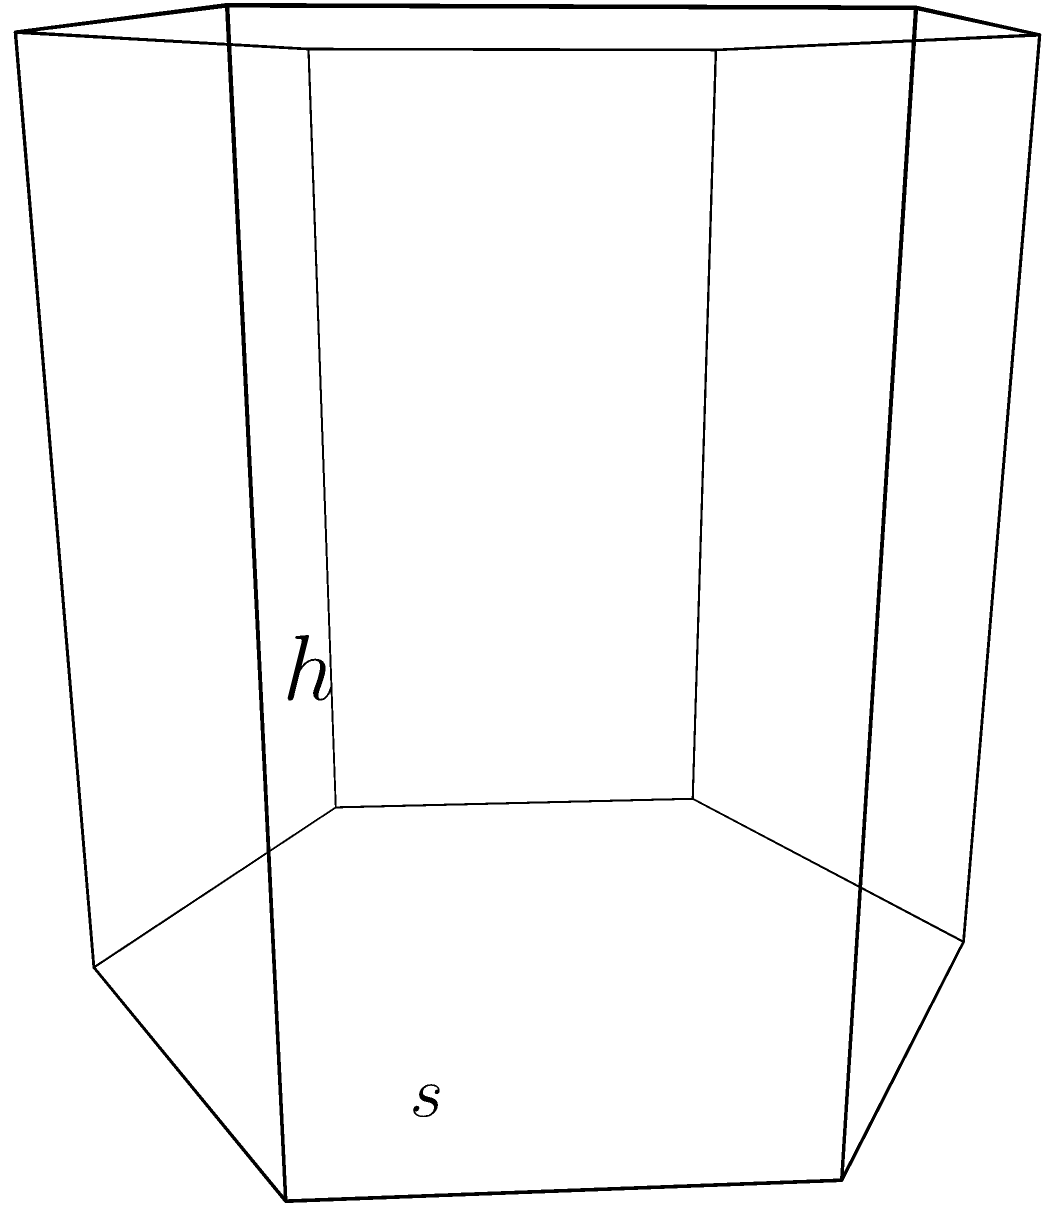As a professional bookmaker, you're designing a question about solid geometry. Consider a regular hexagonal prism with side length $s$ and height $h$. How would you express the lateral surface area of this prism in terms of $s$ and $h$? To find the lateral surface area of a regular hexagonal prism, we can follow these steps:

1) The lateral surface area consists of 6 rectangular faces.

2) Each rectangular face has a width equal to the side length $s$ of the hexagon and a height equal to the height $h$ of the prism.

3) The area of each rectangular face is therefore $s \times h$.

4) Since there are 6 such rectangular faces, we multiply this area by 6.

5) Thus, the lateral surface area $A$ is given by:

   $$A = 6 \times s \times h$$

6) This can be simplified to:

   $$A = 6sh$$

Therefore, the lateral surface area of the regular hexagonal prism is $6sh$ square units.
Answer: $6sh$ 